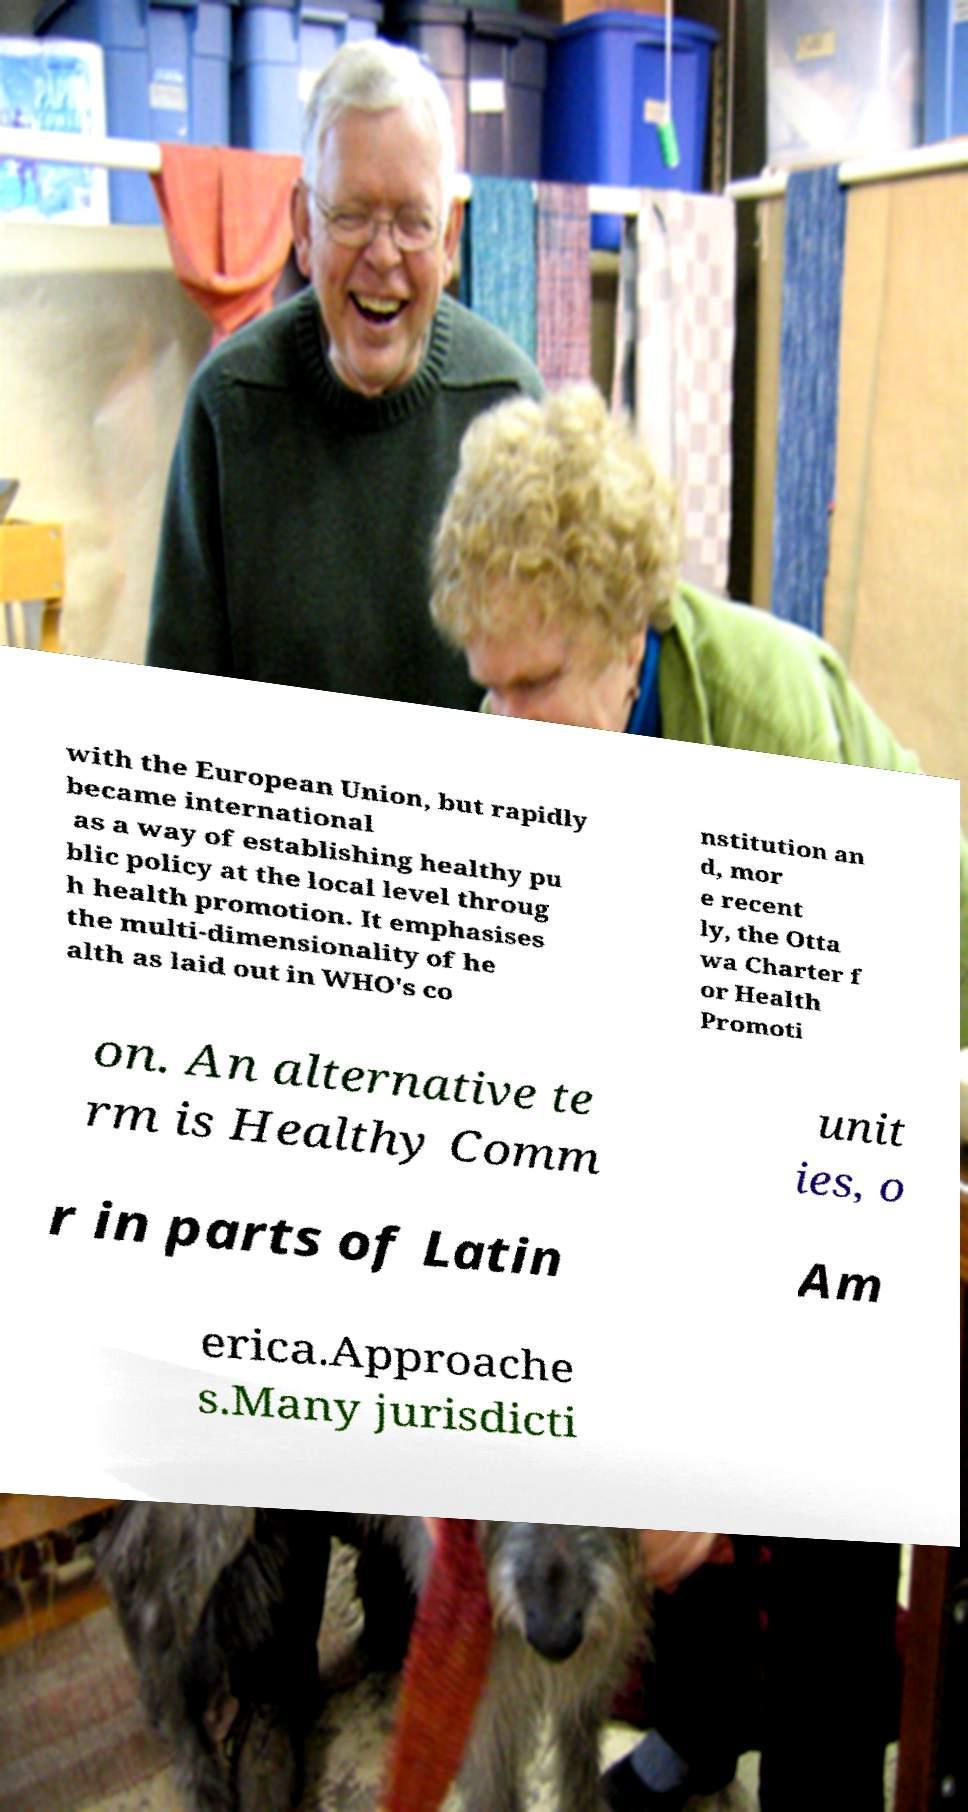Can you read and provide the text displayed in the image?This photo seems to have some interesting text. Can you extract and type it out for me? with the European Union, but rapidly became international as a way of establishing healthy pu blic policy at the local level throug h health promotion. It emphasises the multi-dimensionality of he alth as laid out in WHO's co nstitution an d, mor e recent ly, the Otta wa Charter f or Health Promoti on. An alternative te rm is Healthy Comm unit ies, o r in parts of Latin Am erica.Approache s.Many jurisdicti 